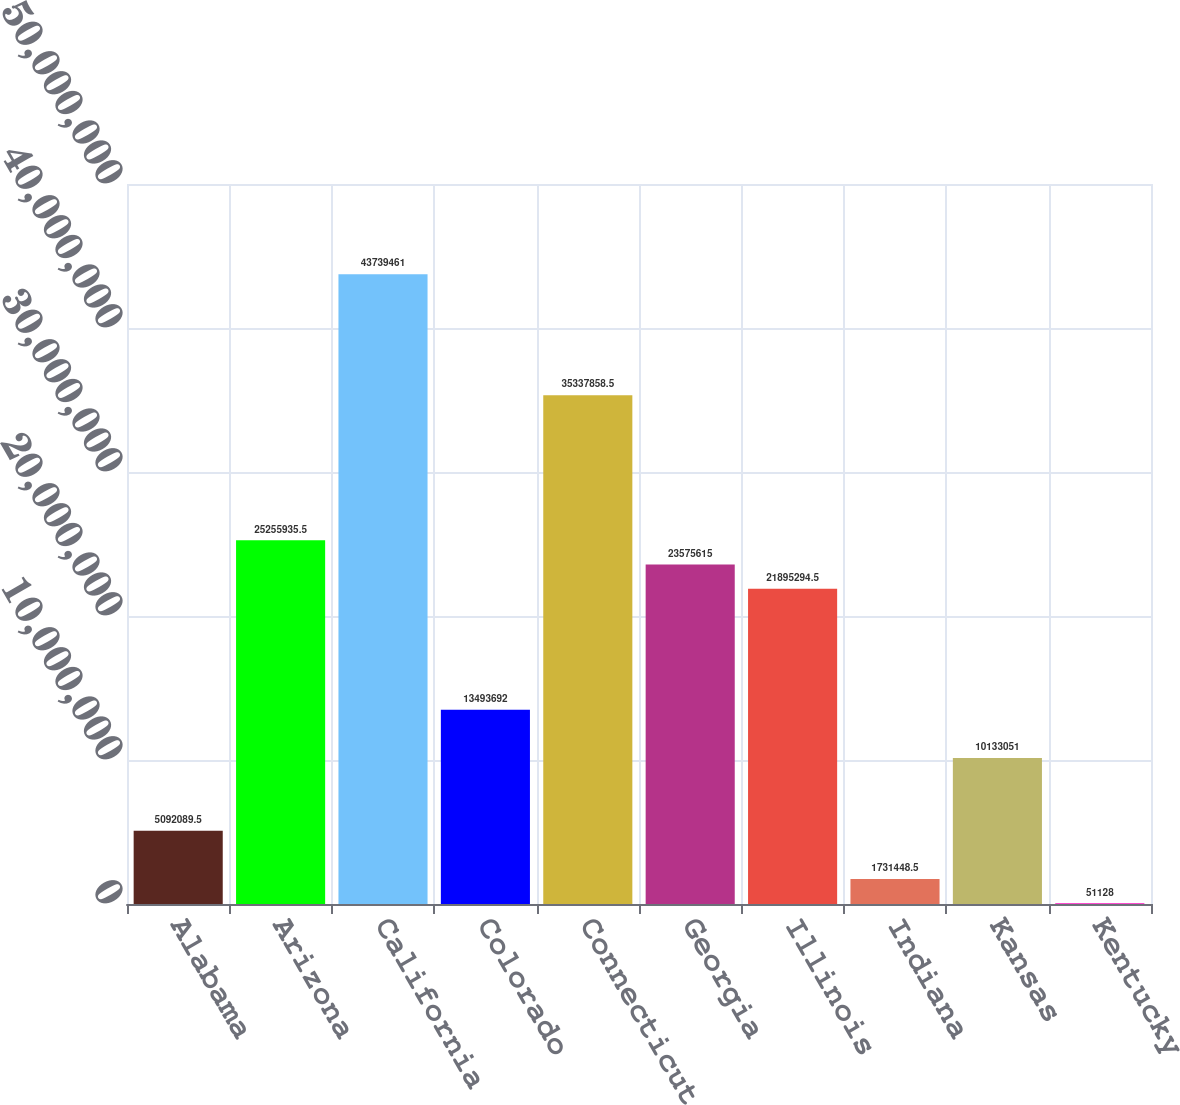<chart> <loc_0><loc_0><loc_500><loc_500><bar_chart><fcel>Alabama<fcel>Arizona<fcel>California<fcel>Colorado<fcel>Connecticut<fcel>Georgia<fcel>Illinois<fcel>Indiana<fcel>Kansas<fcel>Kentucky<nl><fcel>5.09209e+06<fcel>2.52559e+07<fcel>4.37395e+07<fcel>1.34937e+07<fcel>3.53379e+07<fcel>2.35756e+07<fcel>2.18953e+07<fcel>1.73145e+06<fcel>1.01331e+07<fcel>51128<nl></chart> 